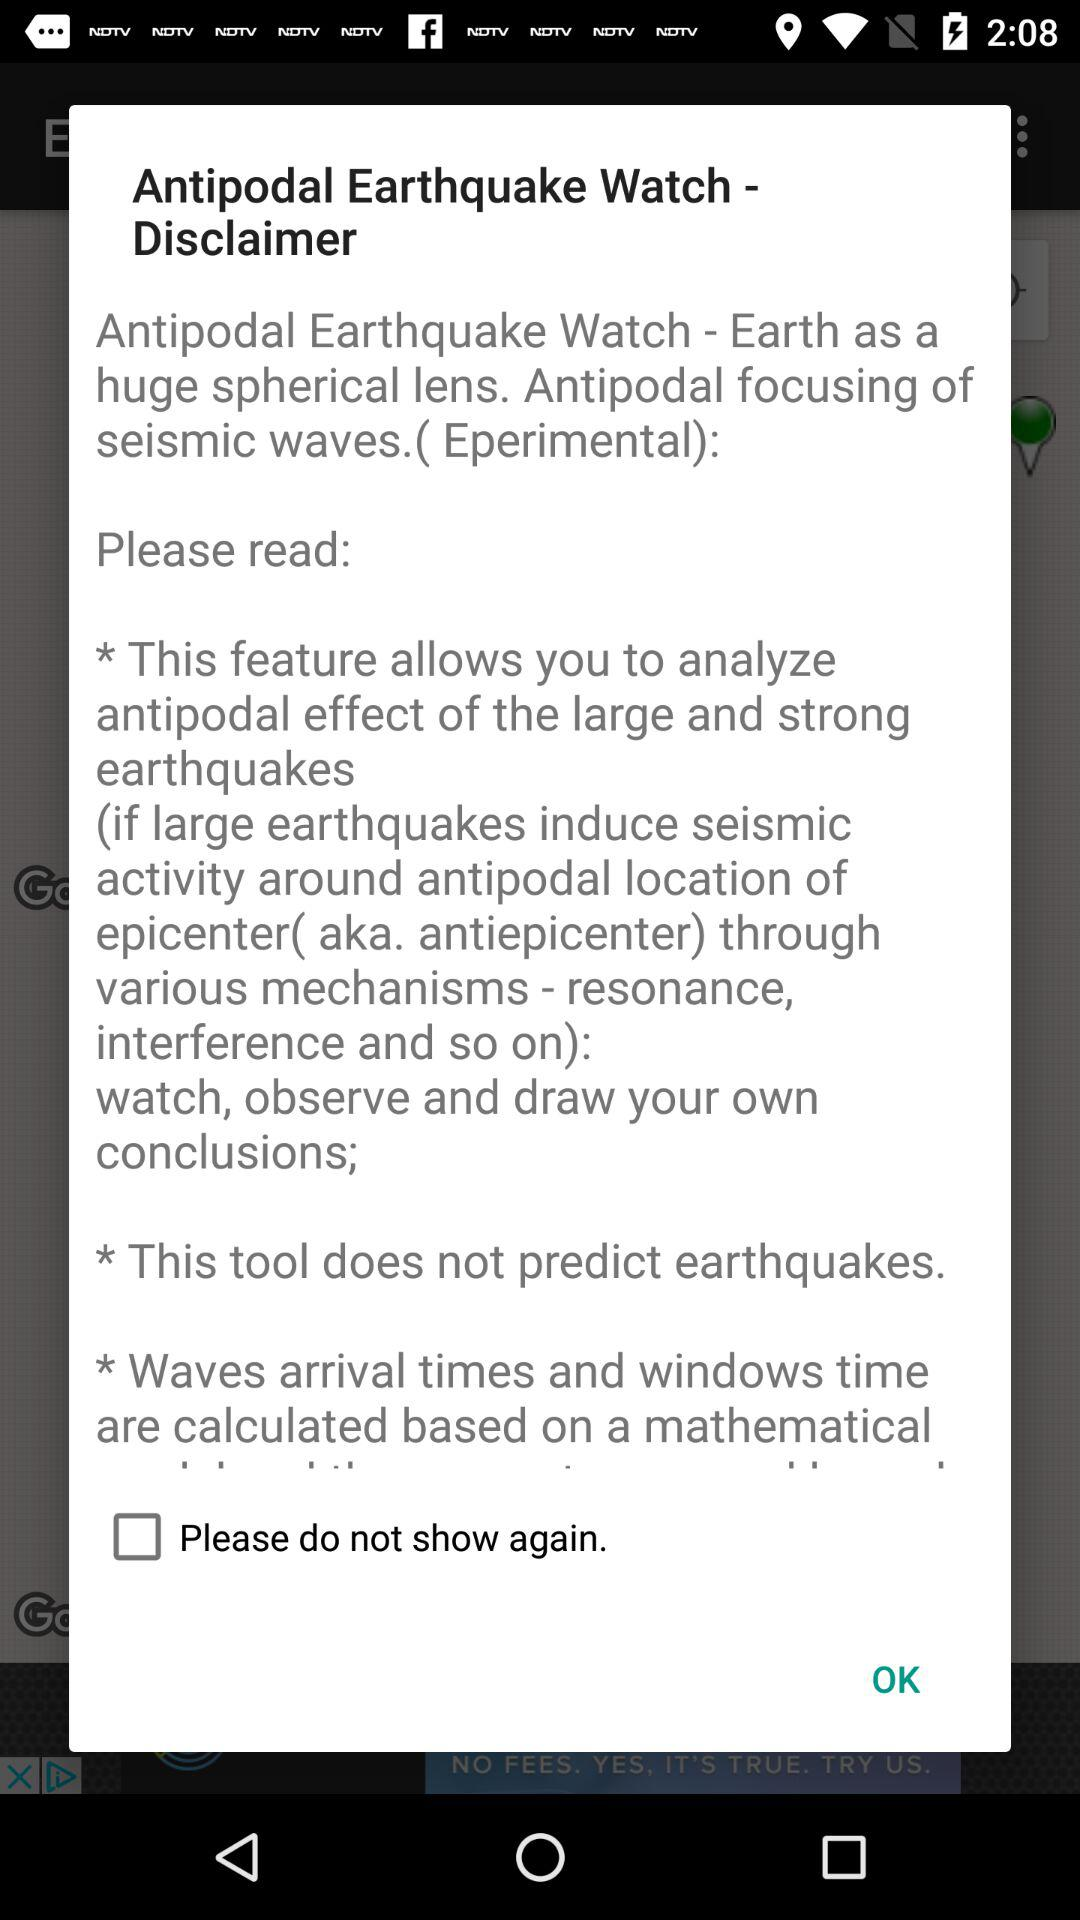What is the application name? The application name is "Antipodal Earthquake Watch". 